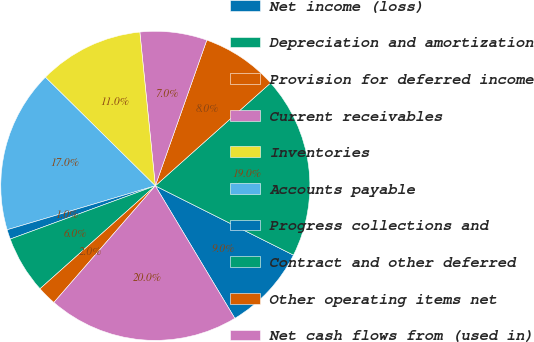Convert chart. <chart><loc_0><loc_0><loc_500><loc_500><pie_chart><fcel>Net income (loss)<fcel>Depreciation and amortization<fcel>Provision for deferred income<fcel>Current receivables<fcel>Inventories<fcel>Accounts payable<fcel>Progress collections and<fcel>Contract and other deferred<fcel>Other operating items net<fcel>Net cash flows from (used in)<nl><fcel>9.0%<fcel>18.99%<fcel>8.0%<fcel>7.0%<fcel>11.0%<fcel>16.99%<fcel>1.01%<fcel>6.0%<fcel>2.01%<fcel>19.99%<nl></chart> 